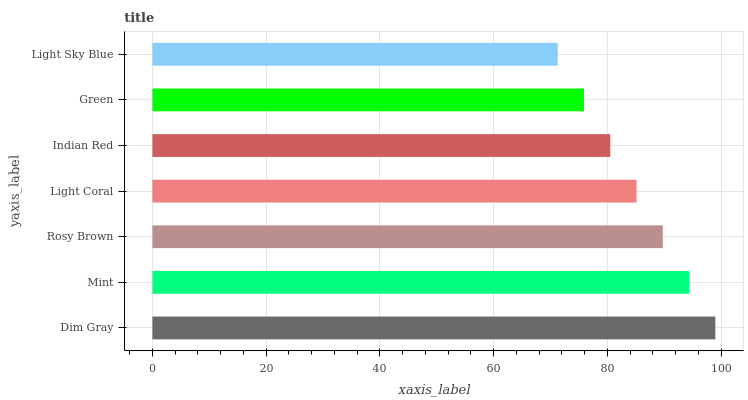Is Light Sky Blue the minimum?
Answer yes or no. Yes. Is Dim Gray the maximum?
Answer yes or no. Yes. Is Mint the minimum?
Answer yes or no. No. Is Mint the maximum?
Answer yes or no. No. Is Dim Gray greater than Mint?
Answer yes or no. Yes. Is Mint less than Dim Gray?
Answer yes or no. Yes. Is Mint greater than Dim Gray?
Answer yes or no. No. Is Dim Gray less than Mint?
Answer yes or no. No. Is Light Coral the high median?
Answer yes or no. Yes. Is Light Coral the low median?
Answer yes or no. Yes. Is Green the high median?
Answer yes or no. No. Is Green the low median?
Answer yes or no. No. 